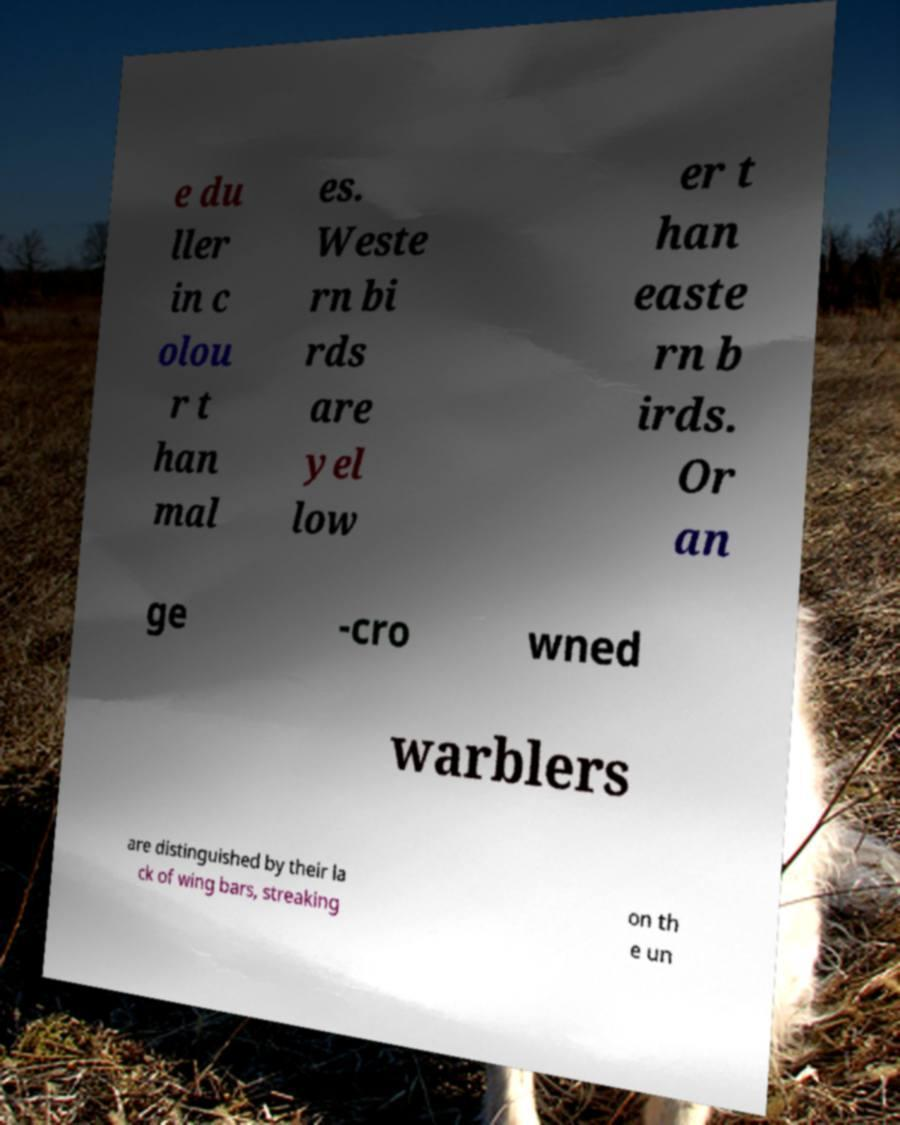There's text embedded in this image that I need extracted. Can you transcribe it verbatim? e du ller in c olou r t han mal es. Weste rn bi rds are yel low er t han easte rn b irds. Or an ge -cro wned warblers are distinguished by their la ck of wing bars, streaking on th e un 